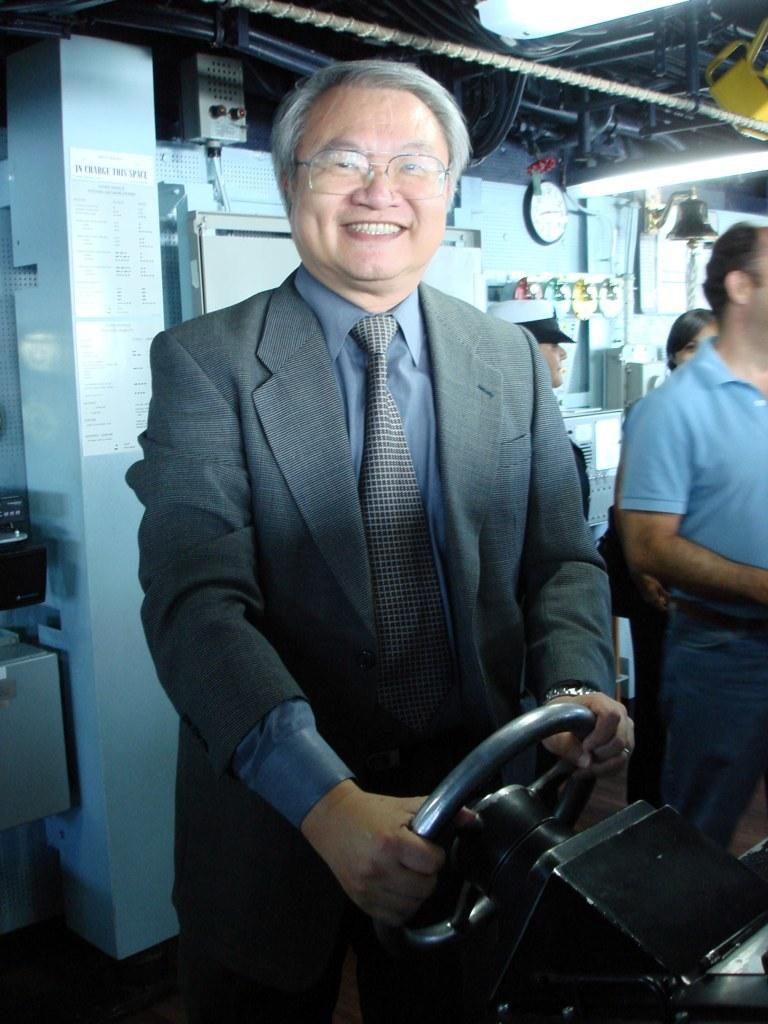What can be seen in the image? There is a person in the image. Can you describe the person's appearance? The person is wearing spectacles. What is the person doing in the image? The person is holding a steering wheel. What else can be seen in the background of the image? There are people and a clock in the background of the image, along with other objects. What color is the person's tongue in the image? There is no information about the person's tongue in the image, as it is not visible. 